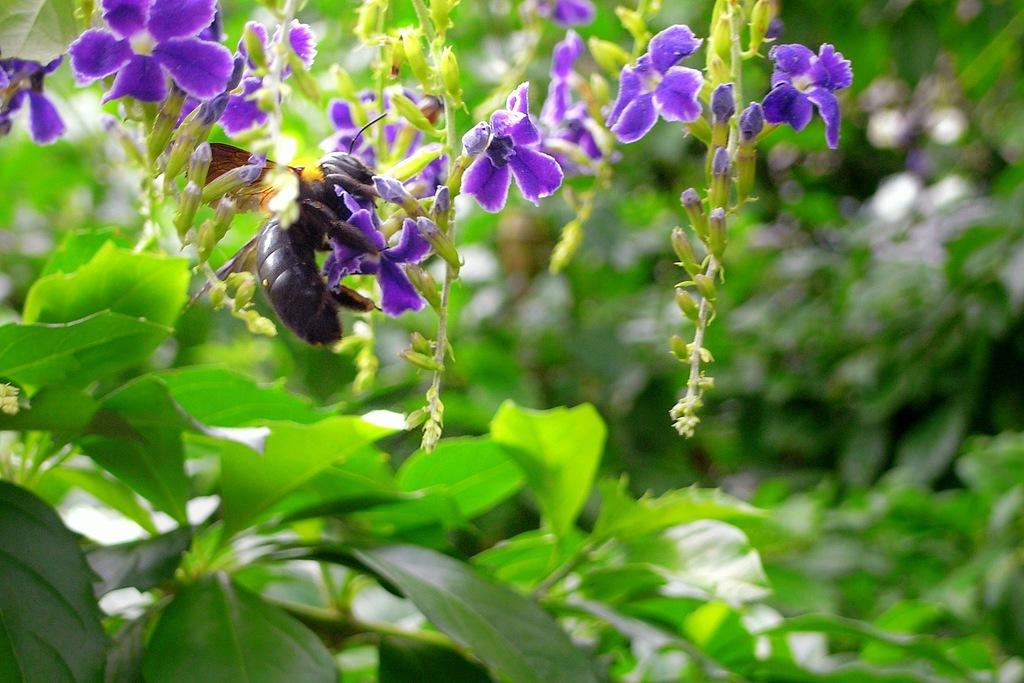What type of insect is in the image? There is a black bee in the image. What is the bee standing on? The bee is standing on a plant. What color are the flowers in the image? There are purple color flowers in the image. What can be seen on the right side of the image? There are plants and trees on the right side of the image. What type of cheese is being thrilled by the bee in the image? There is no cheese present in the image, and the bee is not interacting with any cheese. 